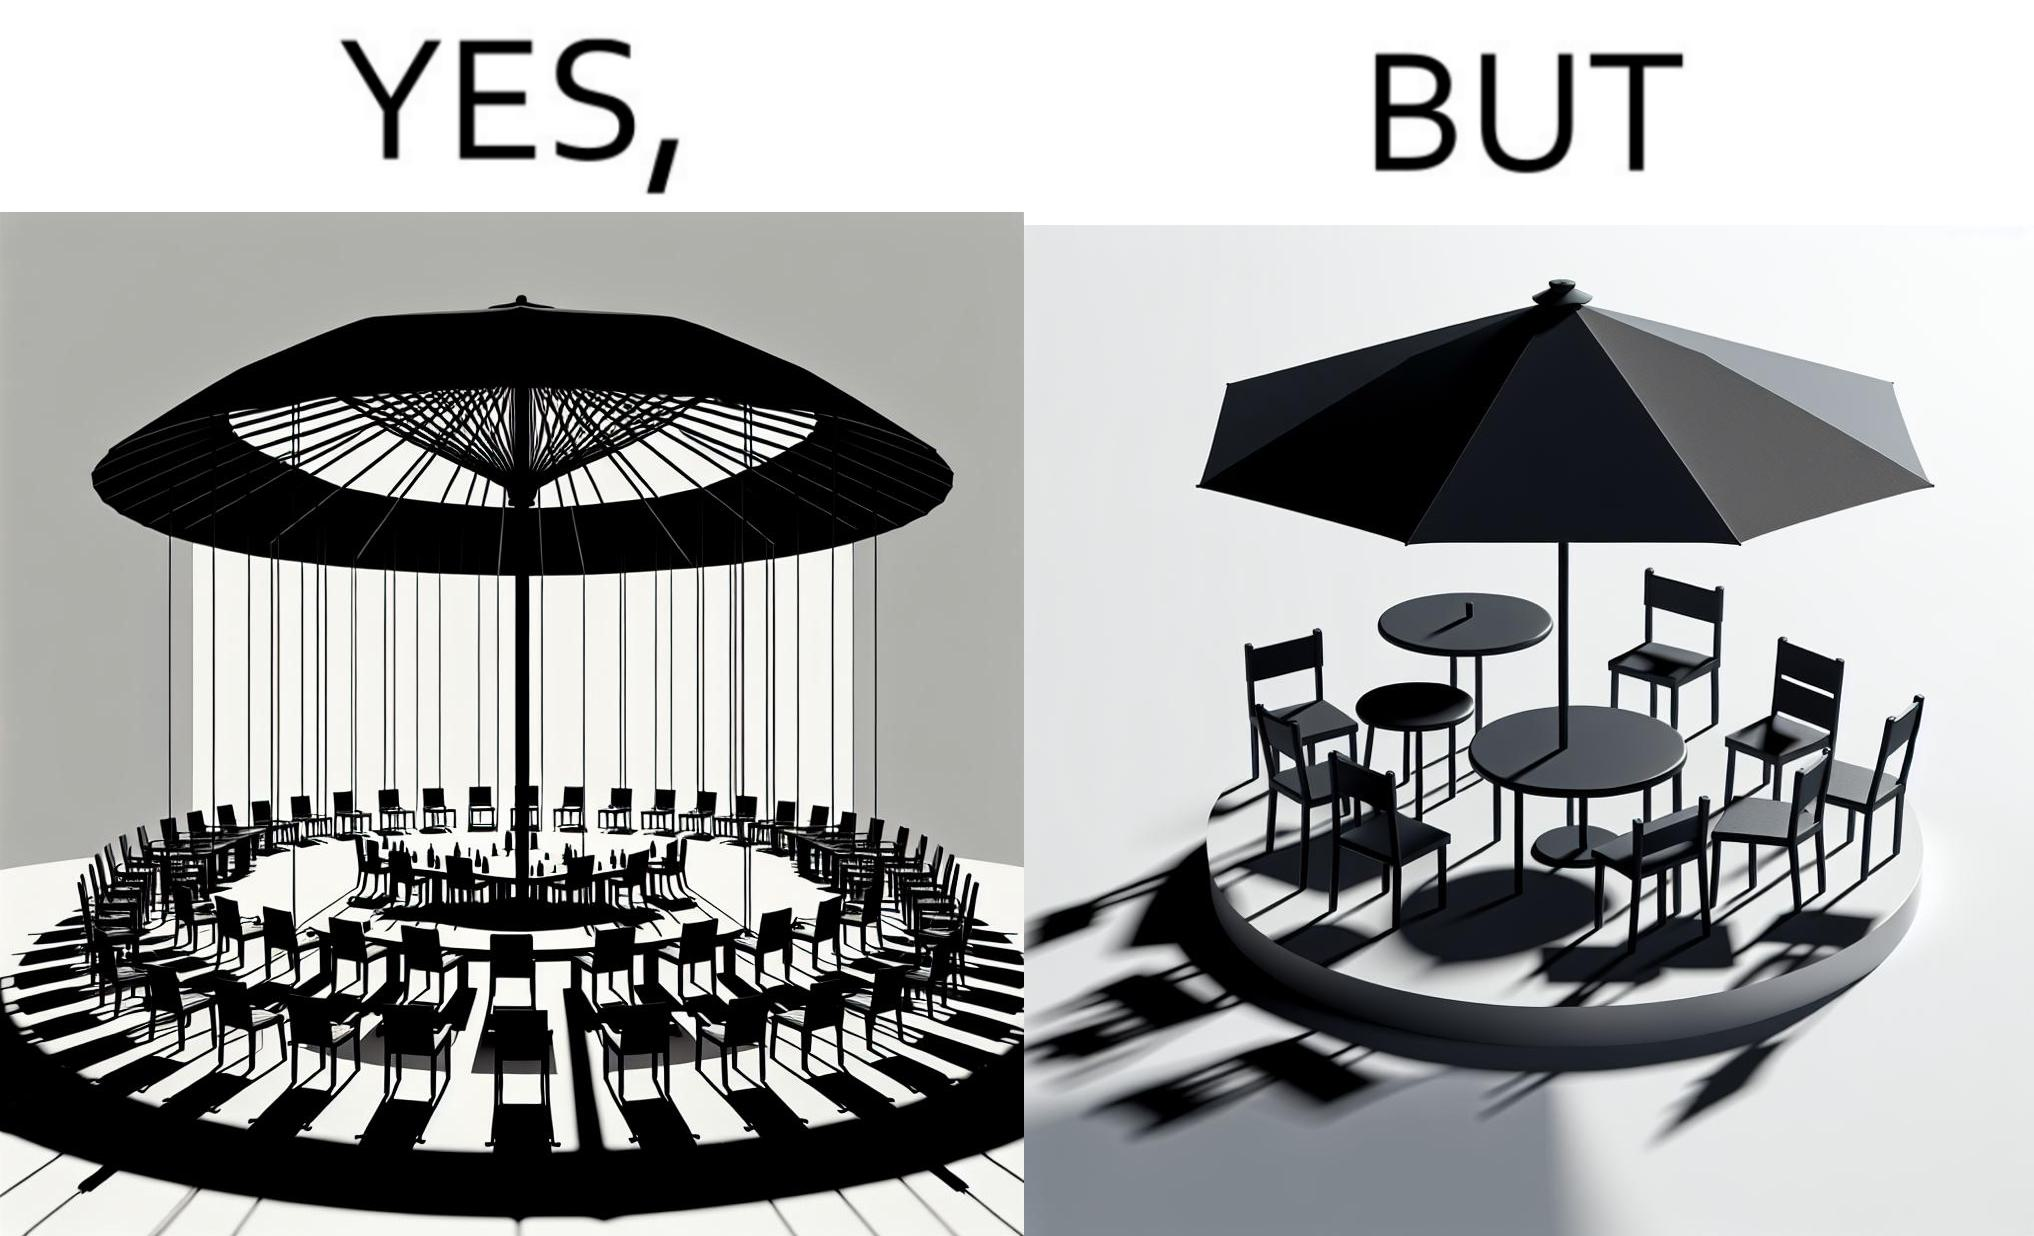What does this image depict? The image is ironical, as the umbrella is meant to provide shadow in the area where the chairs are present, but due to the orientation of the rays of the sun, all the chairs are in sunlight, and the umbrella is of no use in this situation. 